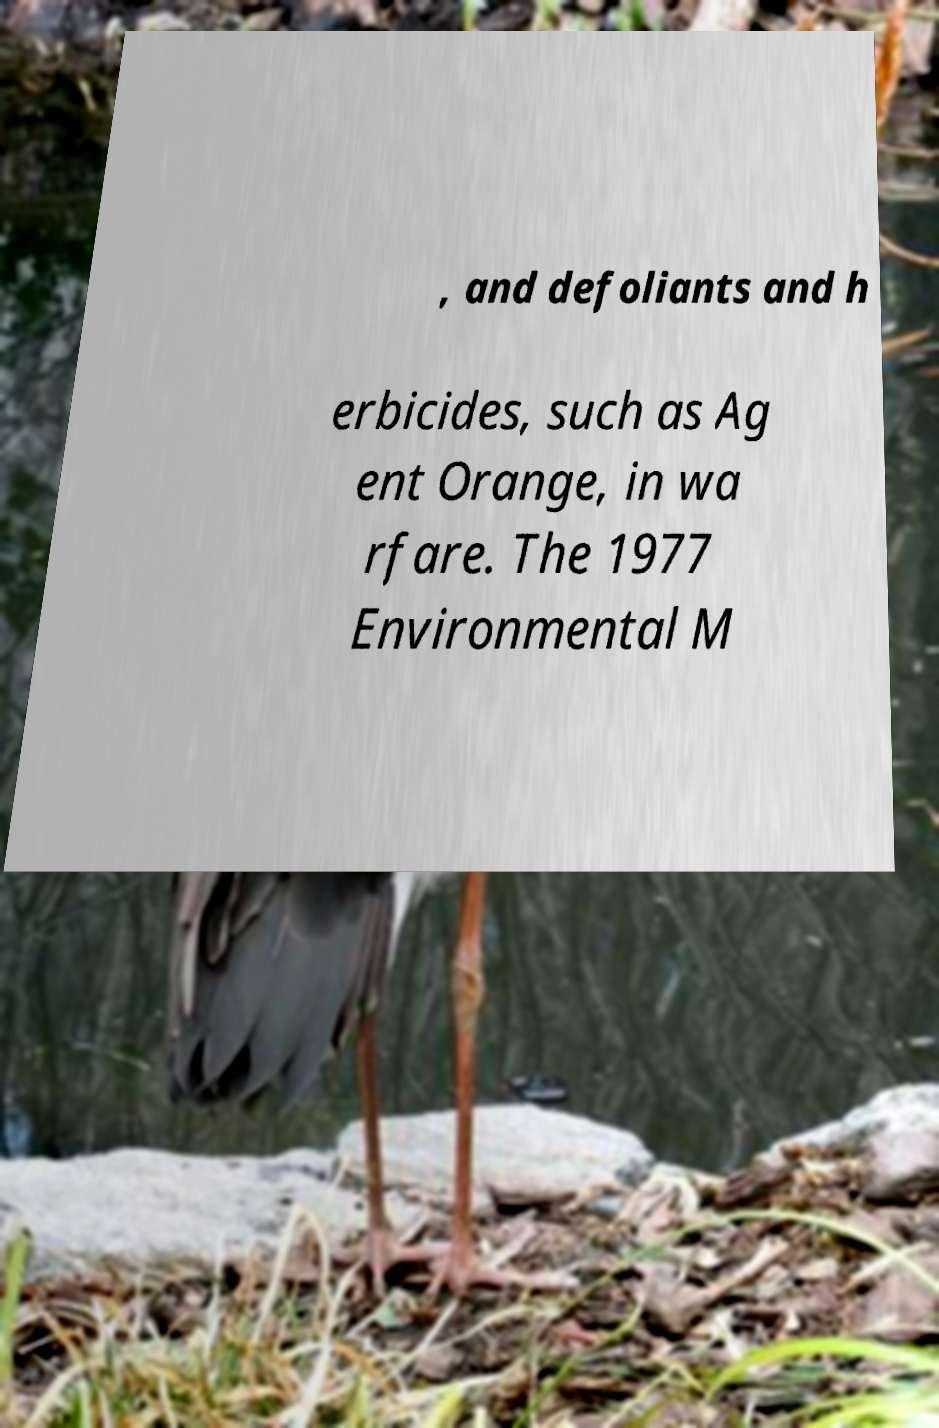There's text embedded in this image that I need extracted. Can you transcribe it verbatim? , and defoliants and h erbicides, such as Ag ent Orange, in wa rfare. The 1977 Environmental M 